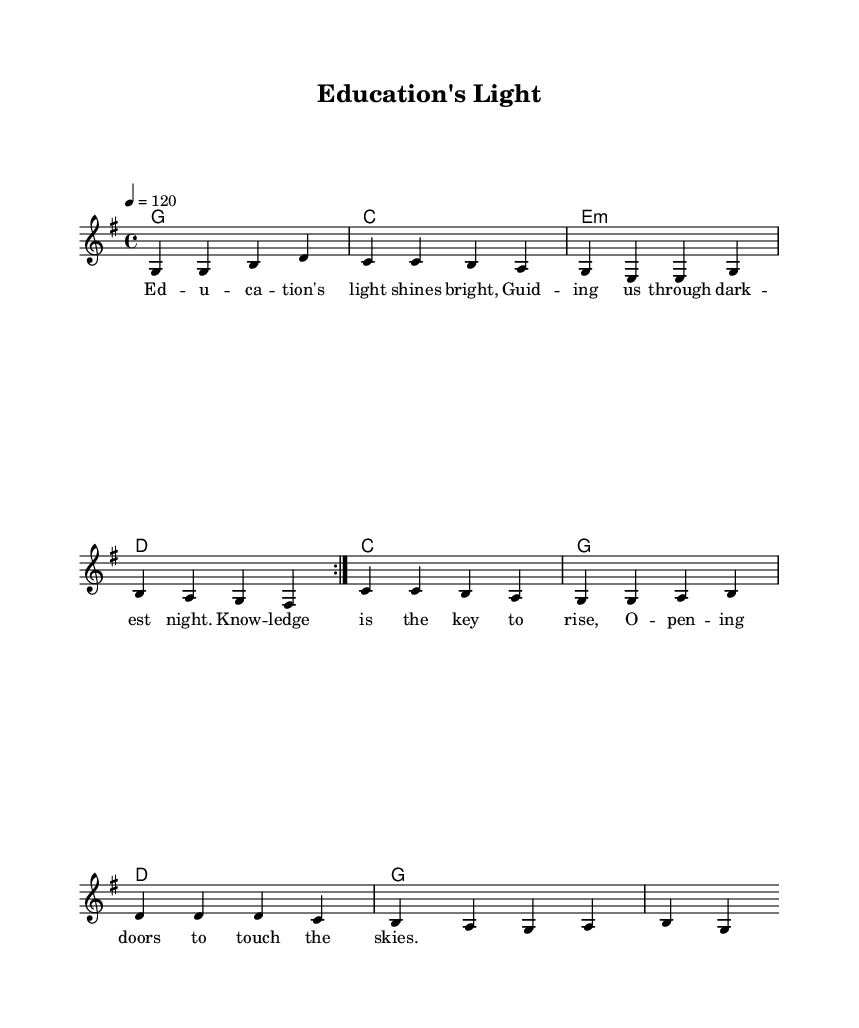What is the key signature of this music? The key signature is G major, which has one sharp (F#) indicated at the beginning of the staff.
Answer: G major What is the time signature of the piece? The time signature is 4/4, meaning there are four beats in each measure and the quarter note gets the beat. This can be seen at the start of the music.
Answer: 4/4 What is the tempo marking for this piece? The tempo marking shows that the piece should be played at a speed of 120 beats per minute, indicated by the notation “\tempo 4 = 120” near the top of the score.
Answer: 120 How many measures are in the repeat section? The repeat section contains four measures, indicated by the “\repeat volta 2” statement which shows that these measures are to be played twice.
Answer: Four What is the theme of the lyrics in this song? The theme of the lyrics focuses on the importance of education, hope, and the potential to rise above challenges. The lyrics emphasize how education acts as a guiding light and opens doors for opportunities.
Answer: Education's light What chord is played on the first measure? The first measure of the score is marked with a G major chord, which can be identified by the notation in the harmonies section where “g1” is written.
Answer: G major What lyrical message is conveyed in the chorus? The chorus conveys a message of guidance through difficult times, emphasizing the power of knowledge to uplift individuals and help them achieve their dreams.
Answer: Guiding us through darkest night 